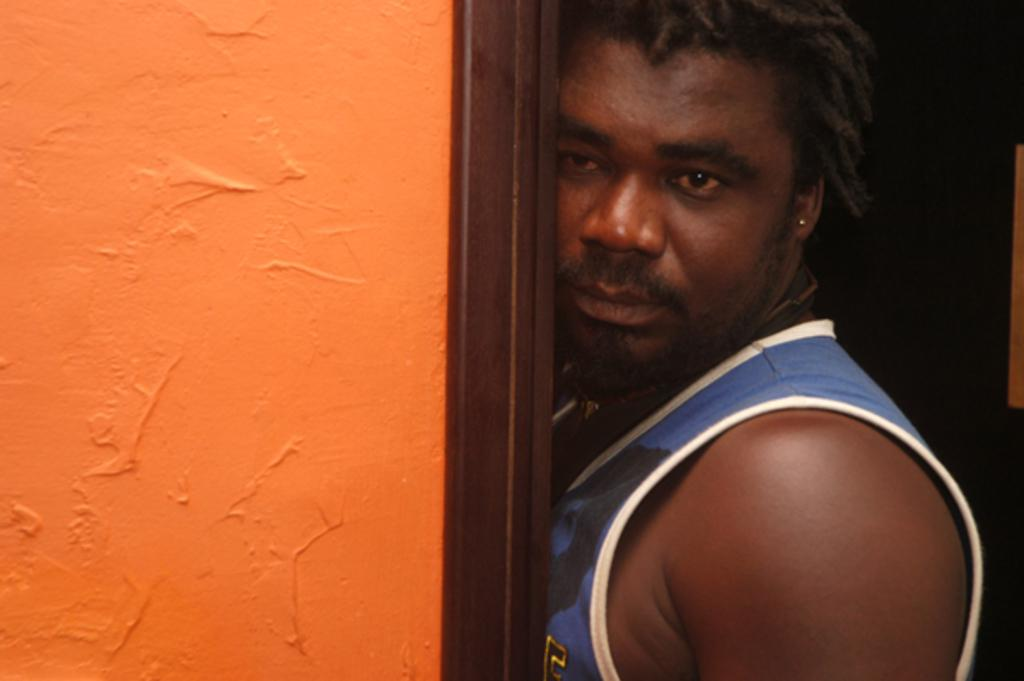Who is present in the image? There is a man in the image. What is the man wearing? The man is wearing a blue T-shirt. What is the man doing in the image? The man is standing. What can be seen behind the man in the image? There is a wall in the image, and it is orange in color. What is the color of the area on the right side of the image? The area on the right side of the image is black. What type of sail can be seen in the image? There is no sail present in the image. What is being exchanged between the man and the wall in the image? There is no exchange happening between the man and the wall in the image. 